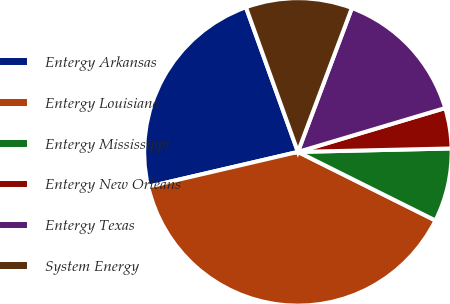<chart> <loc_0><loc_0><loc_500><loc_500><pie_chart><fcel>Entergy Arkansas<fcel>Entergy Louisiana<fcel>Entergy Mississippi<fcel>Entergy New Orleans<fcel>Entergy Texas<fcel>System Energy<nl><fcel>23.15%<fcel>39.0%<fcel>7.72%<fcel>4.25%<fcel>14.68%<fcel>11.2%<nl></chart> 